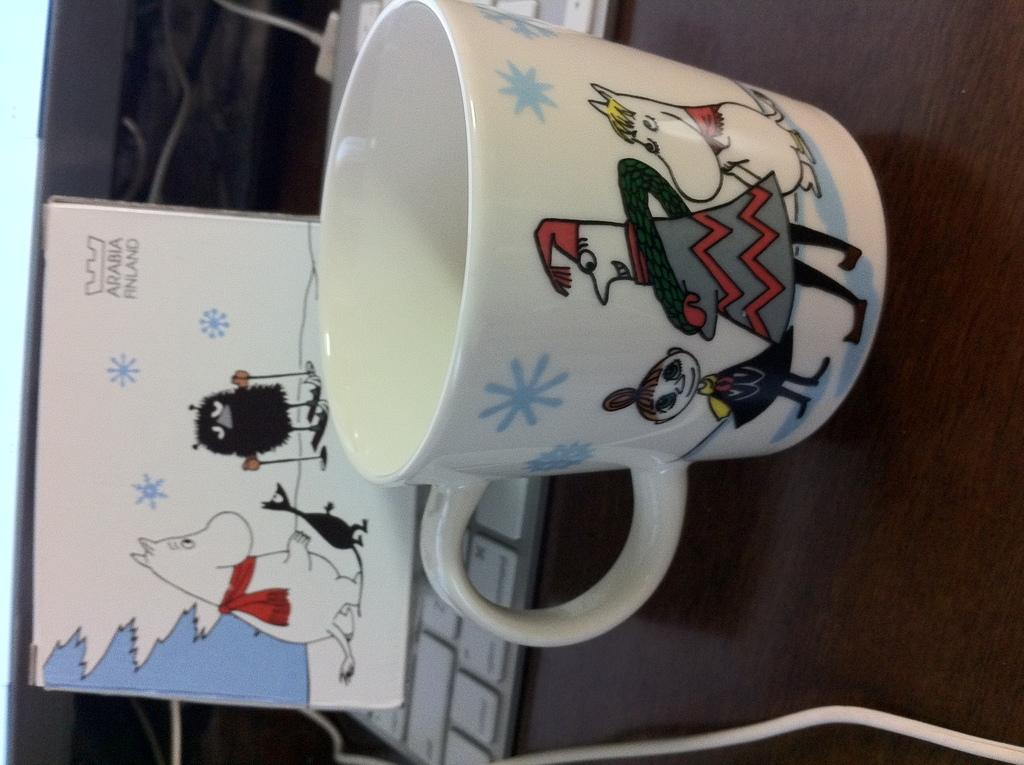What electronic device is visible in the image? There is a keyboard in the image. What type of container is present in the image? There is a cup in the image. What mode of transportation can be seen in the image? There is a car in the image. What connects the various devices or objects in the image? Cables are present in the image. What type of surface do some objects rest on in the image? There are objects on a wooden surface. What is featured on the cup in the image? There are drawings on the cup. What is featured on another object in the image? There are drawings on a card. How many dogs are present in the image? There are no dogs present in the image. What type of plants can be seen growing on the card in the image? There are no plants visible on the card in the image. 